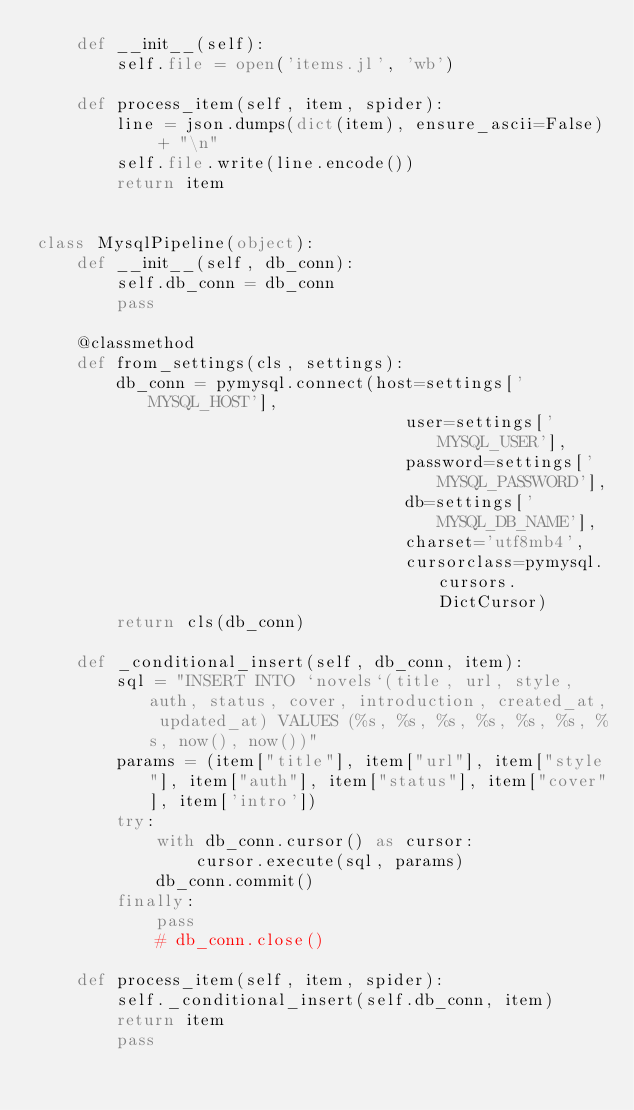Convert code to text. <code><loc_0><loc_0><loc_500><loc_500><_Python_>    def __init__(self):
        self.file = open('items.jl', 'wb')

    def process_item(self, item, spider):
        line = json.dumps(dict(item), ensure_ascii=False) + "\n"
        self.file.write(line.encode())
        return item


class MysqlPipeline(object):
    def __init__(self, db_conn):
        self.db_conn = db_conn
        pass

    @classmethod
    def from_settings(cls, settings):
        db_conn = pymysql.connect(host=settings['MYSQL_HOST'],
                                     user=settings['MYSQL_USER'],
                                     password=settings['MYSQL_PASSWORD'],
                                     db=settings['MYSQL_DB_NAME'],
                                     charset='utf8mb4',
                                     cursorclass=pymysql.cursors.DictCursor)
        return cls(db_conn)

    def _conditional_insert(self, db_conn, item):
        sql = "INSERT INTO `novels`(title, url, style, auth, status, cover, introduction, created_at, updated_at) VALUES (%s, %s, %s, %s, %s, %s, %s, now(), now())"
        params = (item["title"], item["url"], item["style"], item["auth"], item["status"], item["cover"], item['intro'])
        try:
            with db_conn.cursor() as cursor:
                cursor.execute(sql, params)
            db_conn.commit()
        finally:
            pass
            # db_conn.close()

    def process_item(self, item, spider):
        self._conditional_insert(self.db_conn, item)
        return item
        pass
</code> 